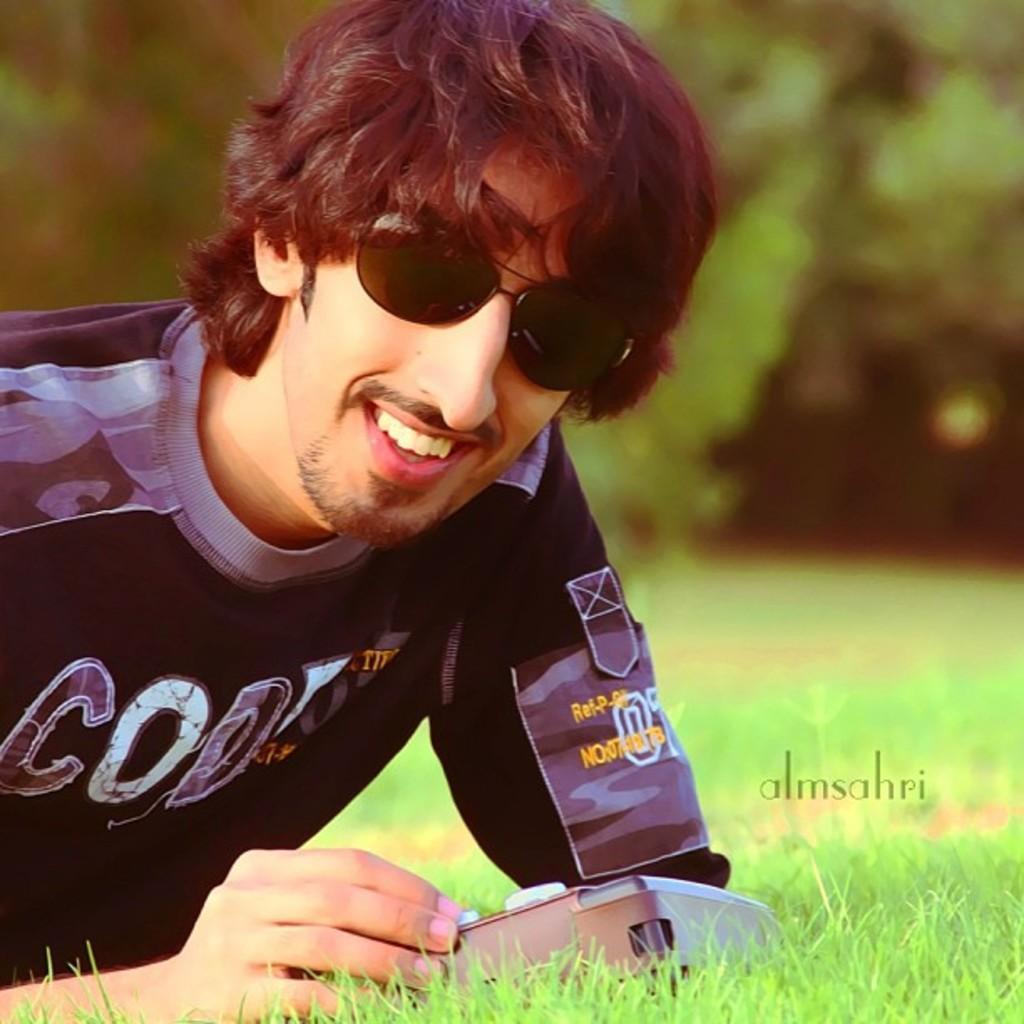Could you give a brief overview of what you see in this image? In the picture we can see a man leaning on the grass surface and he is smiling and in the background, we can see the trees which are not clearly visible. 